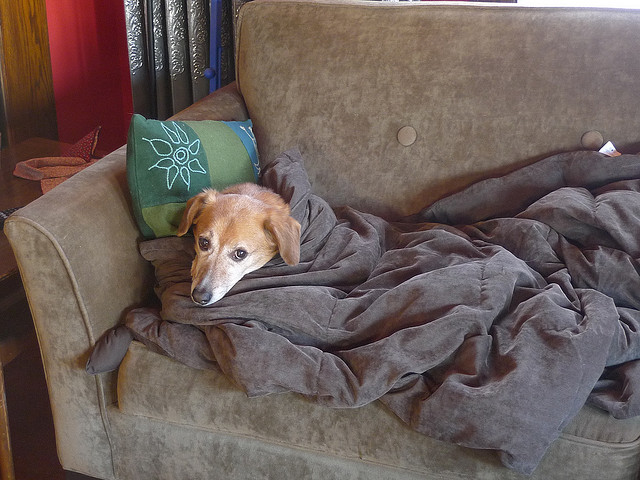<image>What pattern is on the blanket? The blanket has no pattern. It is solid or plain. What pattern is on the blanket? I am not sure what pattern is on the blanket. It can be seen as a solid, solid gray color, plain, comforter or no pattern. 